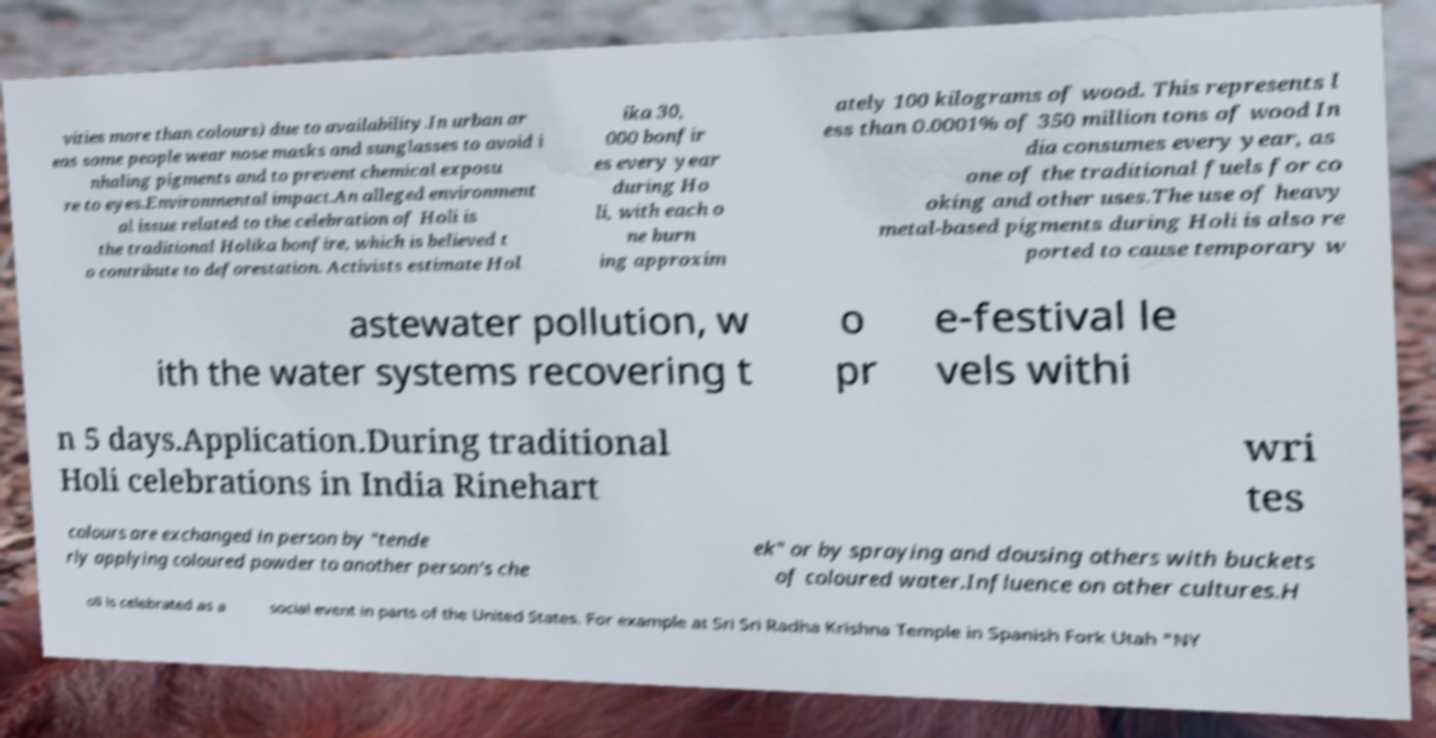For documentation purposes, I need the text within this image transcribed. Could you provide that? vities more than colours) due to availability.In urban ar eas some people wear nose masks and sunglasses to avoid i nhaling pigments and to prevent chemical exposu re to eyes.Environmental impact.An alleged environment al issue related to the celebration of Holi is the traditional Holika bonfire, which is believed t o contribute to deforestation. Activists estimate Hol ika 30, 000 bonfir es every year during Ho li, with each o ne burn ing approxim ately 100 kilograms of wood. This represents l ess than 0.0001% of 350 million tons of wood In dia consumes every year, as one of the traditional fuels for co oking and other uses.The use of heavy metal-based pigments during Holi is also re ported to cause temporary w astewater pollution, w ith the water systems recovering t o pr e-festival le vels withi n 5 days.Application.During traditional Holi celebrations in India Rinehart wri tes colours are exchanged in person by "tende rly applying coloured powder to another person's che ek" or by spraying and dousing others with buckets of coloured water.Influence on other cultures.H oli is celebrated as a social event in parts of the United States. For example at Sri Sri Radha Krishna Temple in Spanish Fork Utah "NY 